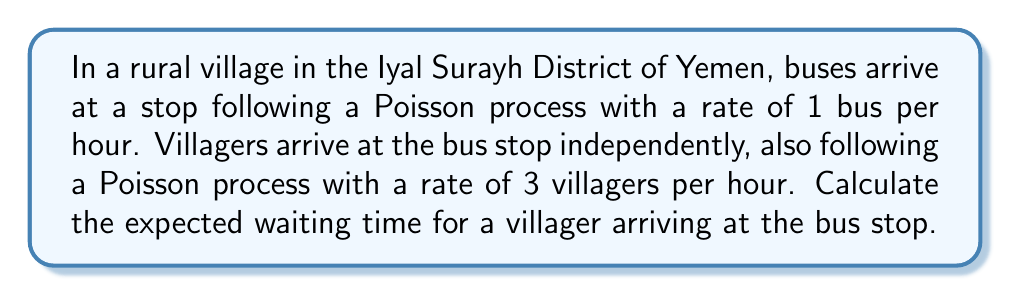What is the answer to this math problem? To solve this problem, we'll use the M/M/1 queuing model, where both arrivals (villagers) and service (buses) follow Poisson processes.

Step 1: Identify the parameters
- Bus arrival rate (service rate): $\mu = 1$ bus/hour
- Villager arrival rate: $\lambda = 3$ villagers/hour

Step 2: Calculate the utilization factor $\rho$
$$\rho = \frac{\lambda}{\mu} = \frac{3}{1} = 3$$

Step 3: Calculate the expected number of villagers in the system (L)
$$L = \frac{\rho}{1-\rho} = \frac{3}{1-3} = -\frac{3}{2}$$

Step 4: Apply Little's Law to find the expected waiting time (W)
Little's Law states that $L = \lambda W$, so:

$$W = \frac{L}{\lambda} = \frac{-\frac{3}{2}}{3} = -\frac{1}{2}$$

Step 5: Interpret the result
The negative waiting time indicates that the system is unstable because the arrival rate of villagers exceeds the service rate of buses. In a real-world scenario, this would lead to an ever-increasing queue of villagers waiting for buses.

Step 6: Calculate the actual expected waiting time
In practice, villagers will wait for the next bus to arrive. Given that bus arrivals follow a Poisson process with rate $\mu = 1$ bus/hour, the expected waiting time is:

$$E[W] = \frac{1}{\mu} = \frac{1}{1} = 1\text{ hour}$$

This is because the time between Poisson events (bus arrivals) follows an exponential distribution with mean $1/\mu$.
Answer: 1 hour 